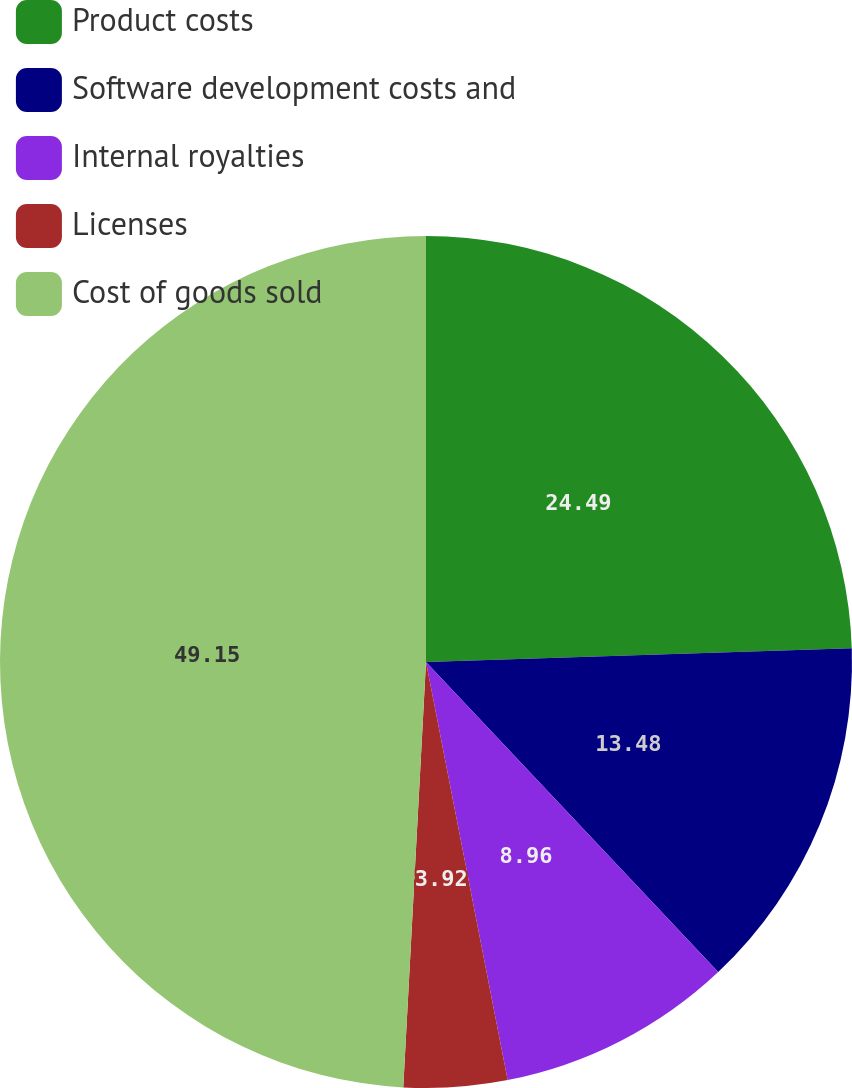Convert chart to OTSL. <chart><loc_0><loc_0><loc_500><loc_500><pie_chart><fcel>Product costs<fcel>Software development costs and<fcel>Internal royalties<fcel>Licenses<fcel>Cost of goods sold<nl><fcel>24.49%<fcel>13.48%<fcel>8.96%<fcel>3.92%<fcel>49.15%<nl></chart> 